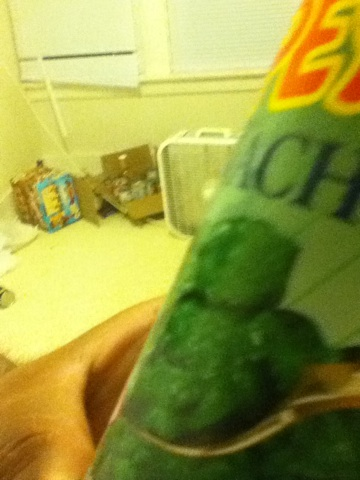Is there a way to determine the freshness of canned spinach? While the image doesn't provide a clear view of expiration dates or labels, canned spinach typically has a long shelf life. To guarantee freshness, always check the expiration date on the can before purchasing or consuming it. 